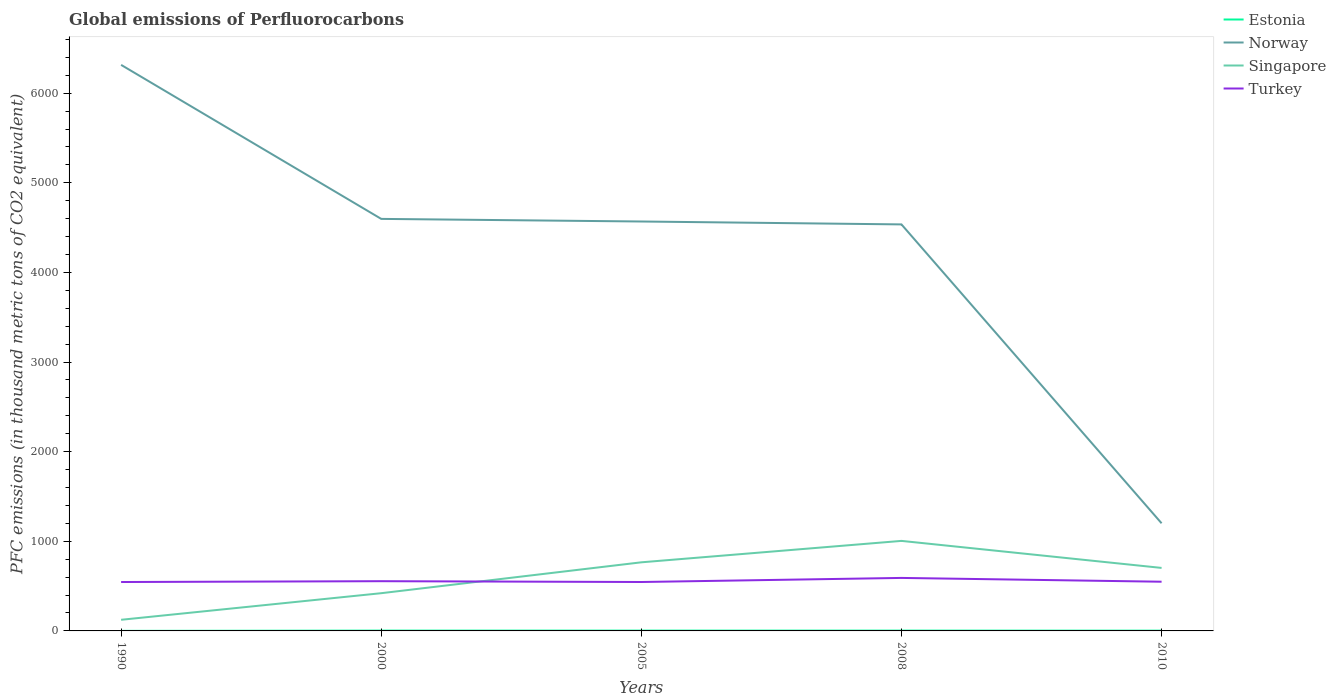Across all years, what is the maximum global emissions of Perfluorocarbons in Turkey?
Ensure brevity in your answer.  545.6. In which year was the global emissions of Perfluorocarbons in Turkey maximum?
Your answer should be very brief. 1990. What is the total global emissions of Perfluorocarbons in Norway in the graph?
Offer a terse response. 1780. What is the difference between the highest and the second highest global emissions of Perfluorocarbons in Singapore?
Your response must be concise. 880.3. Is the global emissions of Perfluorocarbons in Singapore strictly greater than the global emissions of Perfluorocarbons in Turkey over the years?
Your answer should be very brief. No. How many lines are there?
Give a very brief answer. 4. What is the difference between two consecutive major ticks on the Y-axis?
Your response must be concise. 1000. Does the graph contain any zero values?
Offer a very short reply. No. Does the graph contain grids?
Give a very brief answer. No. How are the legend labels stacked?
Your answer should be very brief. Vertical. What is the title of the graph?
Make the answer very short. Global emissions of Perfluorocarbons. Does "Yemen, Rep." appear as one of the legend labels in the graph?
Your answer should be compact. No. What is the label or title of the X-axis?
Provide a succinct answer. Years. What is the label or title of the Y-axis?
Give a very brief answer. PFC emissions (in thousand metric tons of CO2 equivalent). What is the PFC emissions (in thousand metric tons of CO2 equivalent) in Norway in 1990?
Your answer should be compact. 6315.7. What is the PFC emissions (in thousand metric tons of CO2 equivalent) in Singapore in 1990?
Provide a succinct answer. 124.2. What is the PFC emissions (in thousand metric tons of CO2 equivalent) in Turkey in 1990?
Give a very brief answer. 545.6. What is the PFC emissions (in thousand metric tons of CO2 equivalent) of Norway in 2000?
Make the answer very short. 4597.3. What is the PFC emissions (in thousand metric tons of CO2 equivalent) in Singapore in 2000?
Provide a succinct answer. 420.9. What is the PFC emissions (in thousand metric tons of CO2 equivalent) of Turkey in 2000?
Give a very brief answer. 554.9. What is the PFC emissions (in thousand metric tons of CO2 equivalent) of Estonia in 2005?
Offer a very short reply. 3.4. What is the PFC emissions (in thousand metric tons of CO2 equivalent) of Norway in 2005?
Make the answer very short. 4568.1. What is the PFC emissions (in thousand metric tons of CO2 equivalent) of Singapore in 2005?
Offer a terse response. 765.5. What is the PFC emissions (in thousand metric tons of CO2 equivalent) of Turkey in 2005?
Make the answer very short. 545.9. What is the PFC emissions (in thousand metric tons of CO2 equivalent) of Estonia in 2008?
Ensure brevity in your answer.  3.4. What is the PFC emissions (in thousand metric tons of CO2 equivalent) in Norway in 2008?
Your answer should be compact. 4535.7. What is the PFC emissions (in thousand metric tons of CO2 equivalent) of Singapore in 2008?
Provide a short and direct response. 1004.5. What is the PFC emissions (in thousand metric tons of CO2 equivalent) in Turkey in 2008?
Make the answer very short. 591.4. What is the PFC emissions (in thousand metric tons of CO2 equivalent) in Norway in 2010?
Offer a terse response. 1201. What is the PFC emissions (in thousand metric tons of CO2 equivalent) in Singapore in 2010?
Offer a very short reply. 703. What is the PFC emissions (in thousand metric tons of CO2 equivalent) of Turkey in 2010?
Your response must be concise. 549. Across all years, what is the maximum PFC emissions (in thousand metric tons of CO2 equivalent) of Estonia?
Give a very brief answer. 3.5. Across all years, what is the maximum PFC emissions (in thousand metric tons of CO2 equivalent) of Norway?
Your response must be concise. 6315.7. Across all years, what is the maximum PFC emissions (in thousand metric tons of CO2 equivalent) in Singapore?
Your response must be concise. 1004.5. Across all years, what is the maximum PFC emissions (in thousand metric tons of CO2 equivalent) of Turkey?
Give a very brief answer. 591.4. Across all years, what is the minimum PFC emissions (in thousand metric tons of CO2 equivalent) in Estonia?
Your answer should be very brief. 0.5. Across all years, what is the minimum PFC emissions (in thousand metric tons of CO2 equivalent) of Norway?
Offer a very short reply. 1201. Across all years, what is the minimum PFC emissions (in thousand metric tons of CO2 equivalent) of Singapore?
Keep it short and to the point. 124.2. Across all years, what is the minimum PFC emissions (in thousand metric tons of CO2 equivalent) in Turkey?
Offer a very short reply. 545.6. What is the total PFC emissions (in thousand metric tons of CO2 equivalent) of Estonia in the graph?
Your answer should be compact. 13.8. What is the total PFC emissions (in thousand metric tons of CO2 equivalent) of Norway in the graph?
Offer a very short reply. 2.12e+04. What is the total PFC emissions (in thousand metric tons of CO2 equivalent) in Singapore in the graph?
Make the answer very short. 3018.1. What is the total PFC emissions (in thousand metric tons of CO2 equivalent) in Turkey in the graph?
Keep it short and to the point. 2786.8. What is the difference between the PFC emissions (in thousand metric tons of CO2 equivalent) in Norway in 1990 and that in 2000?
Ensure brevity in your answer.  1718.4. What is the difference between the PFC emissions (in thousand metric tons of CO2 equivalent) of Singapore in 1990 and that in 2000?
Your answer should be very brief. -296.7. What is the difference between the PFC emissions (in thousand metric tons of CO2 equivalent) of Turkey in 1990 and that in 2000?
Provide a short and direct response. -9.3. What is the difference between the PFC emissions (in thousand metric tons of CO2 equivalent) of Estonia in 1990 and that in 2005?
Your answer should be compact. -2.9. What is the difference between the PFC emissions (in thousand metric tons of CO2 equivalent) in Norway in 1990 and that in 2005?
Give a very brief answer. 1747.6. What is the difference between the PFC emissions (in thousand metric tons of CO2 equivalent) of Singapore in 1990 and that in 2005?
Your answer should be compact. -641.3. What is the difference between the PFC emissions (in thousand metric tons of CO2 equivalent) in Turkey in 1990 and that in 2005?
Make the answer very short. -0.3. What is the difference between the PFC emissions (in thousand metric tons of CO2 equivalent) of Estonia in 1990 and that in 2008?
Provide a short and direct response. -2.9. What is the difference between the PFC emissions (in thousand metric tons of CO2 equivalent) of Norway in 1990 and that in 2008?
Your response must be concise. 1780. What is the difference between the PFC emissions (in thousand metric tons of CO2 equivalent) in Singapore in 1990 and that in 2008?
Offer a very short reply. -880.3. What is the difference between the PFC emissions (in thousand metric tons of CO2 equivalent) of Turkey in 1990 and that in 2008?
Keep it short and to the point. -45.8. What is the difference between the PFC emissions (in thousand metric tons of CO2 equivalent) in Estonia in 1990 and that in 2010?
Your response must be concise. -2.5. What is the difference between the PFC emissions (in thousand metric tons of CO2 equivalent) of Norway in 1990 and that in 2010?
Make the answer very short. 5114.7. What is the difference between the PFC emissions (in thousand metric tons of CO2 equivalent) of Singapore in 1990 and that in 2010?
Your answer should be compact. -578.8. What is the difference between the PFC emissions (in thousand metric tons of CO2 equivalent) in Norway in 2000 and that in 2005?
Offer a very short reply. 29.2. What is the difference between the PFC emissions (in thousand metric tons of CO2 equivalent) of Singapore in 2000 and that in 2005?
Your answer should be very brief. -344.6. What is the difference between the PFC emissions (in thousand metric tons of CO2 equivalent) in Turkey in 2000 and that in 2005?
Offer a terse response. 9. What is the difference between the PFC emissions (in thousand metric tons of CO2 equivalent) in Norway in 2000 and that in 2008?
Offer a terse response. 61.6. What is the difference between the PFC emissions (in thousand metric tons of CO2 equivalent) in Singapore in 2000 and that in 2008?
Offer a terse response. -583.6. What is the difference between the PFC emissions (in thousand metric tons of CO2 equivalent) of Turkey in 2000 and that in 2008?
Give a very brief answer. -36.5. What is the difference between the PFC emissions (in thousand metric tons of CO2 equivalent) in Estonia in 2000 and that in 2010?
Your response must be concise. 0.5. What is the difference between the PFC emissions (in thousand metric tons of CO2 equivalent) of Norway in 2000 and that in 2010?
Your answer should be very brief. 3396.3. What is the difference between the PFC emissions (in thousand metric tons of CO2 equivalent) in Singapore in 2000 and that in 2010?
Your answer should be compact. -282.1. What is the difference between the PFC emissions (in thousand metric tons of CO2 equivalent) in Turkey in 2000 and that in 2010?
Offer a very short reply. 5.9. What is the difference between the PFC emissions (in thousand metric tons of CO2 equivalent) of Estonia in 2005 and that in 2008?
Your answer should be very brief. 0. What is the difference between the PFC emissions (in thousand metric tons of CO2 equivalent) in Norway in 2005 and that in 2008?
Offer a very short reply. 32.4. What is the difference between the PFC emissions (in thousand metric tons of CO2 equivalent) of Singapore in 2005 and that in 2008?
Your answer should be compact. -239. What is the difference between the PFC emissions (in thousand metric tons of CO2 equivalent) in Turkey in 2005 and that in 2008?
Offer a terse response. -45.5. What is the difference between the PFC emissions (in thousand metric tons of CO2 equivalent) of Estonia in 2005 and that in 2010?
Provide a short and direct response. 0.4. What is the difference between the PFC emissions (in thousand metric tons of CO2 equivalent) of Norway in 2005 and that in 2010?
Provide a short and direct response. 3367.1. What is the difference between the PFC emissions (in thousand metric tons of CO2 equivalent) in Singapore in 2005 and that in 2010?
Offer a terse response. 62.5. What is the difference between the PFC emissions (in thousand metric tons of CO2 equivalent) of Turkey in 2005 and that in 2010?
Ensure brevity in your answer.  -3.1. What is the difference between the PFC emissions (in thousand metric tons of CO2 equivalent) of Estonia in 2008 and that in 2010?
Offer a very short reply. 0.4. What is the difference between the PFC emissions (in thousand metric tons of CO2 equivalent) in Norway in 2008 and that in 2010?
Ensure brevity in your answer.  3334.7. What is the difference between the PFC emissions (in thousand metric tons of CO2 equivalent) in Singapore in 2008 and that in 2010?
Make the answer very short. 301.5. What is the difference between the PFC emissions (in thousand metric tons of CO2 equivalent) in Turkey in 2008 and that in 2010?
Provide a succinct answer. 42.4. What is the difference between the PFC emissions (in thousand metric tons of CO2 equivalent) in Estonia in 1990 and the PFC emissions (in thousand metric tons of CO2 equivalent) in Norway in 2000?
Make the answer very short. -4596.8. What is the difference between the PFC emissions (in thousand metric tons of CO2 equivalent) in Estonia in 1990 and the PFC emissions (in thousand metric tons of CO2 equivalent) in Singapore in 2000?
Your answer should be compact. -420.4. What is the difference between the PFC emissions (in thousand metric tons of CO2 equivalent) of Estonia in 1990 and the PFC emissions (in thousand metric tons of CO2 equivalent) of Turkey in 2000?
Offer a terse response. -554.4. What is the difference between the PFC emissions (in thousand metric tons of CO2 equivalent) of Norway in 1990 and the PFC emissions (in thousand metric tons of CO2 equivalent) of Singapore in 2000?
Ensure brevity in your answer.  5894.8. What is the difference between the PFC emissions (in thousand metric tons of CO2 equivalent) of Norway in 1990 and the PFC emissions (in thousand metric tons of CO2 equivalent) of Turkey in 2000?
Your response must be concise. 5760.8. What is the difference between the PFC emissions (in thousand metric tons of CO2 equivalent) of Singapore in 1990 and the PFC emissions (in thousand metric tons of CO2 equivalent) of Turkey in 2000?
Offer a terse response. -430.7. What is the difference between the PFC emissions (in thousand metric tons of CO2 equivalent) of Estonia in 1990 and the PFC emissions (in thousand metric tons of CO2 equivalent) of Norway in 2005?
Offer a terse response. -4567.6. What is the difference between the PFC emissions (in thousand metric tons of CO2 equivalent) in Estonia in 1990 and the PFC emissions (in thousand metric tons of CO2 equivalent) in Singapore in 2005?
Make the answer very short. -765. What is the difference between the PFC emissions (in thousand metric tons of CO2 equivalent) of Estonia in 1990 and the PFC emissions (in thousand metric tons of CO2 equivalent) of Turkey in 2005?
Provide a short and direct response. -545.4. What is the difference between the PFC emissions (in thousand metric tons of CO2 equivalent) in Norway in 1990 and the PFC emissions (in thousand metric tons of CO2 equivalent) in Singapore in 2005?
Your answer should be compact. 5550.2. What is the difference between the PFC emissions (in thousand metric tons of CO2 equivalent) in Norway in 1990 and the PFC emissions (in thousand metric tons of CO2 equivalent) in Turkey in 2005?
Your answer should be compact. 5769.8. What is the difference between the PFC emissions (in thousand metric tons of CO2 equivalent) of Singapore in 1990 and the PFC emissions (in thousand metric tons of CO2 equivalent) of Turkey in 2005?
Ensure brevity in your answer.  -421.7. What is the difference between the PFC emissions (in thousand metric tons of CO2 equivalent) of Estonia in 1990 and the PFC emissions (in thousand metric tons of CO2 equivalent) of Norway in 2008?
Offer a very short reply. -4535.2. What is the difference between the PFC emissions (in thousand metric tons of CO2 equivalent) in Estonia in 1990 and the PFC emissions (in thousand metric tons of CO2 equivalent) in Singapore in 2008?
Keep it short and to the point. -1004. What is the difference between the PFC emissions (in thousand metric tons of CO2 equivalent) in Estonia in 1990 and the PFC emissions (in thousand metric tons of CO2 equivalent) in Turkey in 2008?
Provide a succinct answer. -590.9. What is the difference between the PFC emissions (in thousand metric tons of CO2 equivalent) of Norway in 1990 and the PFC emissions (in thousand metric tons of CO2 equivalent) of Singapore in 2008?
Your response must be concise. 5311.2. What is the difference between the PFC emissions (in thousand metric tons of CO2 equivalent) in Norway in 1990 and the PFC emissions (in thousand metric tons of CO2 equivalent) in Turkey in 2008?
Provide a succinct answer. 5724.3. What is the difference between the PFC emissions (in thousand metric tons of CO2 equivalent) in Singapore in 1990 and the PFC emissions (in thousand metric tons of CO2 equivalent) in Turkey in 2008?
Your response must be concise. -467.2. What is the difference between the PFC emissions (in thousand metric tons of CO2 equivalent) in Estonia in 1990 and the PFC emissions (in thousand metric tons of CO2 equivalent) in Norway in 2010?
Provide a short and direct response. -1200.5. What is the difference between the PFC emissions (in thousand metric tons of CO2 equivalent) in Estonia in 1990 and the PFC emissions (in thousand metric tons of CO2 equivalent) in Singapore in 2010?
Your answer should be compact. -702.5. What is the difference between the PFC emissions (in thousand metric tons of CO2 equivalent) of Estonia in 1990 and the PFC emissions (in thousand metric tons of CO2 equivalent) of Turkey in 2010?
Keep it short and to the point. -548.5. What is the difference between the PFC emissions (in thousand metric tons of CO2 equivalent) in Norway in 1990 and the PFC emissions (in thousand metric tons of CO2 equivalent) in Singapore in 2010?
Your answer should be compact. 5612.7. What is the difference between the PFC emissions (in thousand metric tons of CO2 equivalent) in Norway in 1990 and the PFC emissions (in thousand metric tons of CO2 equivalent) in Turkey in 2010?
Give a very brief answer. 5766.7. What is the difference between the PFC emissions (in thousand metric tons of CO2 equivalent) of Singapore in 1990 and the PFC emissions (in thousand metric tons of CO2 equivalent) of Turkey in 2010?
Provide a short and direct response. -424.8. What is the difference between the PFC emissions (in thousand metric tons of CO2 equivalent) in Estonia in 2000 and the PFC emissions (in thousand metric tons of CO2 equivalent) in Norway in 2005?
Your answer should be compact. -4564.6. What is the difference between the PFC emissions (in thousand metric tons of CO2 equivalent) of Estonia in 2000 and the PFC emissions (in thousand metric tons of CO2 equivalent) of Singapore in 2005?
Your response must be concise. -762. What is the difference between the PFC emissions (in thousand metric tons of CO2 equivalent) of Estonia in 2000 and the PFC emissions (in thousand metric tons of CO2 equivalent) of Turkey in 2005?
Make the answer very short. -542.4. What is the difference between the PFC emissions (in thousand metric tons of CO2 equivalent) in Norway in 2000 and the PFC emissions (in thousand metric tons of CO2 equivalent) in Singapore in 2005?
Offer a terse response. 3831.8. What is the difference between the PFC emissions (in thousand metric tons of CO2 equivalent) of Norway in 2000 and the PFC emissions (in thousand metric tons of CO2 equivalent) of Turkey in 2005?
Offer a very short reply. 4051.4. What is the difference between the PFC emissions (in thousand metric tons of CO2 equivalent) in Singapore in 2000 and the PFC emissions (in thousand metric tons of CO2 equivalent) in Turkey in 2005?
Make the answer very short. -125. What is the difference between the PFC emissions (in thousand metric tons of CO2 equivalent) of Estonia in 2000 and the PFC emissions (in thousand metric tons of CO2 equivalent) of Norway in 2008?
Your answer should be very brief. -4532.2. What is the difference between the PFC emissions (in thousand metric tons of CO2 equivalent) in Estonia in 2000 and the PFC emissions (in thousand metric tons of CO2 equivalent) in Singapore in 2008?
Your response must be concise. -1001. What is the difference between the PFC emissions (in thousand metric tons of CO2 equivalent) in Estonia in 2000 and the PFC emissions (in thousand metric tons of CO2 equivalent) in Turkey in 2008?
Provide a short and direct response. -587.9. What is the difference between the PFC emissions (in thousand metric tons of CO2 equivalent) of Norway in 2000 and the PFC emissions (in thousand metric tons of CO2 equivalent) of Singapore in 2008?
Your answer should be very brief. 3592.8. What is the difference between the PFC emissions (in thousand metric tons of CO2 equivalent) of Norway in 2000 and the PFC emissions (in thousand metric tons of CO2 equivalent) of Turkey in 2008?
Your answer should be compact. 4005.9. What is the difference between the PFC emissions (in thousand metric tons of CO2 equivalent) in Singapore in 2000 and the PFC emissions (in thousand metric tons of CO2 equivalent) in Turkey in 2008?
Your answer should be very brief. -170.5. What is the difference between the PFC emissions (in thousand metric tons of CO2 equivalent) in Estonia in 2000 and the PFC emissions (in thousand metric tons of CO2 equivalent) in Norway in 2010?
Your answer should be very brief. -1197.5. What is the difference between the PFC emissions (in thousand metric tons of CO2 equivalent) in Estonia in 2000 and the PFC emissions (in thousand metric tons of CO2 equivalent) in Singapore in 2010?
Provide a succinct answer. -699.5. What is the difference between the PFC emissions (in thousand metric tons of CO2 equivalent) in Estonia in 2000 and the PFC emissions (in thousand metric tons of CO2 equivalent) in Turkey in 2010?
Make the answer very short. -545.5. What is the difference between the PFC emissions (in thousand metric tons of CO2 equivalent) in Norway in 2000 and the PFC emissions (in thousand metric tons of CO2 equivalent) in Singapore in 2010?
Offer a very short reply. 3894.3. What is the difference between the PFC emissions (in thousand metric tons of CO2 equivalent) of Norway in 2000 and the PFC emissions (in thousand metric tons of CO2 equivalent) of Turkey in 2010?
Your response must be concise. 4048.3. What is the difference between the PFC emissions (in thousand metric tons of CO2 equivalent) in Singapore in 2000 and the PFC emissions (in thousand metric tons of CO2 equivalent) in Turkey in 2010?
Provide a short and direct response. -128.1. What is the difference between the PFC emissions (in thousand metric tons of CO2 equivalent) in Estonia in 2005 and the PFC emissions (in thousand metric tons of CO2 equivalent) in Norway in 2008?
Offer a terse response. -4532.3. What is the difference between the PFC emissions (in thousand metric tons of CO2 equivalent) in Estonia in 2005 and the PFC emissions (in thousand metric tons of CO2 equivalent) in Singapore in 2008?
Make the answer very short. -1001.1. What is the difference between the PFC emissions (in thousand metric tons of CO2 equivalent) of Estonia in 2005 and the PFC emissions (in thousand metric tons of CO2 equivalent) of Turkey in 2008?
Your response must be concise. -588. What is the difference between the PFC emissions (in thousand metric tons of CO2 equivalent) in Norway in 2005 and the PFC emissions (in thousand metric tons of CO2 equivalent) in Singapore in 2008?
Offer a terse response. 3563.6. What is the difference between the PFC emissions (in thousand metric tons of CO2 equivalent) in Norway in 2005 and the PFC emissions (in thousand metric tons of CO2 equivalent) in Turkey in 2008?
Offer a very short reply. 3976.7. What is the difference between the PFC emissions (in thousand metric tons of CO2 equivalent) in Singapore in 2005 and the PFC emissions (in thousand metric tons of CO2 equivalent) in Turkey in 2008?
Your response must be concise. 174.1. What is the difference between the PFC emissions (in thousand metric tons of CO2 equivalent) in Estonia in 2005 and the PFC emissions (in thousand metric tons of CO2 equivalent) in Norway in 2010?
Give a very brief answer. -1197.6. What is the difference between the PFC emissions (in thousand metric tons of CO2 equivalent) in Estonia in 2005 and the PFC emissions (in thousand metric tons of CO2 equivalent) in Singapore in 2010?
Offer a very short reply. -699.6. What is the difference between the PFC emissions (in thousand metric tons of CO2 equivalent) of Estonia in 2005 and the PFC emissions (in thousand metric tons of CO2 equivalent) of Turkey in 2010?
Make the answer very short. -545.6. What is the difference between the PFC emissions (in thousand metric tons of CO2 equivalent) in Norway in 2005 and the PFC emissions (in thousand metric tons of CO2 equivalent) in Singapore in 2010?
Keep it short and to the point. 3865.1. What is the difference between the PFC emissions (in thousand metric tons of CO2 equivalent) in Norway in 2005 and the PFC emissions (in thousand metric tons of CO2 equivalent) in Turkey in 2010?
Offer a terse response. 4019.1. What is the difference between the PFC emissions (in thousand metric tons of CO2 equivalent) of Singapore in 2005 and the PFC emissions (in thousand metric tons of CO2 equivalent) of Turkey in 2010?
Offer a terse response. 216.5. What is the difference between the PFC emissions (in thousand metric tons of CO2 equivalent) in Estonia in 2008 and the PFC emissions (in thousand metric tons of CO2 equivalent) in Norway in 2010?
Offer a very short reply. -1197.6. What is the difference between the PFC emissions (in thousand metric tons of CO2 equivalent) of Estonia in 2008 and the PFC emissions (in thousand metric tons of CO2 equivalent) of Singapore in 2010?
Keep it short and to the point. -699.6. What is the difference between the PFC emissions (in thousand metric tons of CO2 equivalent) in Estonia in 2008 and the PFC emissions (in thousand metric tons of CO2 equivalent) in Turkey in 2010?
Offer a very short reply. -545.6. What is the difference between the PFC emissions (in thousand metric tons of CO2 equivalent) of Norway in 2008 and the PFC emissions (in thousand metric tons of CO2 equivalent) of Singapore in 2010?
Provide a short and direct response. 3832.7. What is the difference between the PFC emissions (in thousand metric tons of CO2 equivalent) in Norway in 2008 and the PFC emissions (in thousand metric tons of CO2 equivalent) in Turkey in 2010?
Your response must be concise. 3986.7. What is the difference between the PFC emissions (in thousand metric tons of CO2 equivalent) of Singapore in 2008 and the PFC emissions (in thousand metric tons of CO2 equivalent) of Turkey in 2010?
Give a very brief answer. 455.5. What is the average PFC emissions (in thousand metric tons of CO2 equivalent) in Estonia per year?
Your response must be concise. 2.76. What is the average PFC emissions (in thousand metric tons of CO2 equivalent) in Norway per year?
Give a very brief answer. 4243.56. What is the average PFC emissions (in thousand metric tons of CO2 equivalent) in Singapore per year?
Your response must be concise. 603.62. What is the average PFC emissions (in thousand metric tons of CO2 equivalent) of Turkey per year?
Your answer should be very brief. 557.36. In the year 1990, what is the difference between the PFC emissions (in thousand metric tons of CO2 equivalent) in Estonia and PFC emissions (in thousand metric tons of CO2 equivalent) in Norway?
Your answer should be very brief. -6315.2. In the year 1990, what is the difference between the PFC emissions (in thousand metric tons of CO2 equivalent) of Estonia and PFC emissions (in thousand metric tons of CO2 equivalent) of Singapore?
Your response must be concise. -123.7. In the year 1990, what is the difference between the PFC emissions (in thousand metric tons of CO2 equivalent) of Estonia and PFC emissions (in thousand metric tons of CO2 equivalent) of Turkey?
Offer a terse response. -545.1. In the year 1990, what is the difference between the PFC emissions (in thousand metric tons of CO2 equivalent) of Norway and PFC emissions (in thousand metric tons of CO2 equivalent) of Singapore?
Ensure brevity in your answer.  6191.5. In the year 1990, what is the difference between the PFC emissions (in thousand metric tons of CO2 equivalent) of Norway and PFC emissions (in thousand metric tons of CO2 equivalent) of Turkey?
Ensure brevity in your answer.  5770.1. In the year 1990, what is the difference between the PFC emissions (in thousand metric tons of CO2 equivalent) in Singapore and PFC emissions (in thousand metric tons of CO2 equivalent) in Turkey?
Provide a short and direct response. -421.4. In the year 2000, what is the difference between the PFC emissions (in thousand metric tons of CO2 equivalent) of Estonia and PFC emissions (in thousand metric tons of CO2 equivalent) of Norway?
Provide a succinct answer. -4593.8. In the year 2000, what is the difference between the PFC emissions (in thousand metric tons of CO2 equivalent) in Estonia and PFC emissions (in thousand metric tons of CO2 equivalent) in Singapore?
Make the answer very short. -417.4. In the year 2000, what is the difference between the PFC emissions (in thousand metric tons of CO2 equivalent) in Estonia and PFC emissions (in thousand metric tons of CO2 equivalent) in Turkey?
Make the answer very short. -551.4. In the year 2000, what is the difference between the PFC emissions (in thousand metric tons of CO2 equivalent) of Norway and PFC emissions (in thousand metric tons of CO2 equivalent) of Singapore?
Your response must be concise. 4176.4. In the year 2000, what is the difference between the PFC emissions (in thousand metric tons of CO2 equivalent) of Norway and PFC emissions (in thousand metric tons of CO2 equivalent) of Turkey?
Give a very brief answer. 4042.4. In the year 2000, what is the difference between the PFC emissions (in thousand metric tons of CO2 equivalent) in Singapore and PFC emissions (in thousand metric tons of CO2 equivalent) in Turkey?
Give a very brief answer. -134. In the year 2005, what is the difference between the PFC emissions (in thousand metric tons of CO2 equivalent) in Estonia and PFC emissions (in thousand metric tons of CO2 equivalent) in Norway?
Ensure brevity in your answer.  -4564.7. In the year 2005, what is the difference between the PFC emissions (in thousand metric tons of CO2 equivalent) in Estonia and PFC emissions (in thousand metric tons of CO2 equivalent) in Singapore?
Offer a terse response. -762.1. In the year 2005, what is the difference between the PFC emissions (in thousand metric tons of CO2 equivalent) in Estonia and PFC emissions (in thousand metric tons of CO2 equivalent) in Turkey?
Your response must be concise. -542.5. In the year 2005, what is the difference between the PFC emissions (in thousand metric tons of CO2 equivalent) of Norway and PFC emissions (in thousand metric tons of CO2 equivalent) of Singapore?
Give a very brief answer. 3802.6. In the year 2005, what is the difference between the PFC emissions (in thousand metric tons of CO2 equivalent) of Norway and PFC emissions (in thousand metric tons of CO2 equivalent) of Turkey?
Offer a very short reply. 4022.2. In the year 2005, what is the difference between the PFC emissions (in thousand metric tons of CO2 equivalent) in Singapore and PFC emissions (in thousand metric tons of CO2 equivalent) in Turkey?
Your answer should be compact. 219.6. In the year 2008, what is the difference between the PFC emissions (in thousand metric tons of CO2 equivalent) of Estonia and PFC emissions (in thousand metric tons of CO2 equivalent) of Norway?
Your response must be concise. -4532.3. In the year 2008, what is the difference between the PFC emissions (in thousand metric tons of CO2 equivalent) of Estonia and PFC emissions (in thousand metric tons of CO2 equivalent) of Singapore?
Your response must be concise. -1001.1. In the year 2008, what is the difference between the PFC emissions (in thousand metric tons of CO2 equivalent) of Estonia and PFC emissions (in thousand metric tons of CO2 equivalent) of Turkey?
Keep it short and to the point. -588. In the year 2008, what is the difference between the PFC emissions (in thousand metric tons of CO2 equivalent) in Norway and PFC emissions (in thousand metric tons of CO2 equivalent) in Singapore?
Provide a succinct answer. 3531.2. In the year 2008, what is the difference between the PFC emissions (in thousand metric tons of CO2 equivalent) in Norway and PFC emissions (in thousand metric tons of CO2 equivalent) in Turkey?
Your response must be concise. 3944.3. In the year 2008, what is the difference between the PFC emissions (in thousand metric tons of CO2 equivalent) of Singapore and PFC emissions (in thousand metric tons of CO2 equivalent) of Turkey?
Your response must be concise. 413.1. In the year 2010, what is the difference between the PFC emissions (in thousand metric tons of CO2 equivalent) in Estonia and PFC emissions (in thousand metric tons of CO2 equivalent) in Norway?
Offer a very short reply. -1198. In the year 2010, what is the difference between the PFC emissions (in thousand metric tons of CO2 equivalent) in Estonia and PFC emissions (in thousand metric tons of CO2 equivalent) in Singapore?
Ensure brevity in your answer.  -700. In the year 2010, what is the difference between the PFC emissions (in thousand metric tons of CO2 equivalent) in Estonia and PFC emissions (in thousand metric tons of CO2 equivalent) in Turkey?
Provide a succinct answer. -546. In the year 2010, what is the difference between the PFC emissions (in thousand metric tons of CO2 equivalent) of Norway and PFC emissions (in thousand metric tons of CO2 equivalent) of Singapore?
Offer a very short reply. 498. In the year 2010, what is the difference between the PFC emissions (in thousand metric tons of CO2 equivalent) in Norway and PFC emissions (in thousand metric tons of CO2 equivalent) in Turkey?
Your answer should be very brief. 652. In the year 2010, what is the difference between the PFC emissions (in thousand metric tons of CO2 equivalent) of Singapore and PFC emissions (in thousand metric tons of CO2 equivalent) of Turkey?
Give a very brief answer. 154. What is the ratio of the PFC emissions (in thousand metric tons of CO2 equivalent) in Estonia in 1990 to that in 2000?
Give a very brief answer. 0.14. What is the ratio of the PFC emissions (in thousand metric tons of CO2 equivalent) of Norway in 1990 to that in 2000?
Make the answer very short. 1.37. What is the ratio of the PFC emissions (in thousand metric tons of CO2 equivalent) of Singapore in 1990 to that in 2000?
Your response must be concise. 0.3. What is the ratio of the PFC emissions (in thousand metric tons of CO2 equivalent) in Turkey in 1990 to that in 2000?
Your answer should be compact. 0.98. What is the ratio of the PFC emissions (in thousand metric tons of CO2 equivalent) in Estonia in 1990 to that in 2005?
Give a very brief answer. 0.15. What is the ratio of the PFC emissions (in thousand metric tons of CO2 equivalent) of Norway in 1990 to that in 2005?
Make the answer very short. 1.38. What is the ratio of the PFC emissions (in thousand metric tons of CO2 equivalent) in Singapore in 1990 to that in 2005?
Offer a terse response. 0.16. What is the ratio of the PFC emissions (in thousand metric tons of CO2 equivalent) in Turkey in 1990 to that in 2005?
Make the answer very short. 1. What is the ratio of the PFC emissions (in thousand metric tons of CO2 equivalent) in Estonia in 1990 to that in 2008?
Your answer should be compact. 0.15. What is the ratio of the PFC emissions (in thousand metric tons of CO2 equivalent) in Norway in 1990 to that in 2008?
Offer a very short reply. 1.39. What is the ratio of the PFC emissions (in thousand metric tons of CO2 equivalent) in Singapore in 1990 to that in 2008?
Provide a short and direct response. 0.12. What is the ratio of the PFC emissions (in thousand metric tons of CO2 equivalent) in Turkey in 1990 to that in 2008?
Ensure brevity in your answer.  0.92. What is the ratio of the PFC emissions (in thousand metric tons of CO2 equivalent) of Norway in 1990 to that in 2010?
Your response must be concise. 5.26. What is the ratio of the PFC emissions (in thousand metric tons of CO2 equivalent) of Singapore in 1990 to that in 2010?
Make the answer very short. 0.18. What is the ratio of the PFC emissions (in thousand metric tons of CO2 equivalent) in Turkey in 1990 to that in 2010?
Keep it short and to the point. 0.99. What is the ratio of the PFC emissions (in thousand metric tons of CO2 equivalent) in Estonia in 2000 to that in 2005?
Give a very brief answer. 1.03. What is the ratio of the PFC emissions (in thousand metric tons of CO2 equivalent) in Norway in 2000 to that in 2005?
Your answer should be very brief. 1.01. What is the ratio of the PFC emissions (in thousand metric tons of CO2 equivalent) in Singapore in 2000 to that in 2005?
Offer a terse response. 0.55. What is the ratio of the PFC emissions (in thousand metric tons of CO2 equivalent) of Turkey in 2000 to that in 2005?
Provide a short and direct response. 1.02. What is the ratio of the PFC emissions (in thousand metric tons of CO2 equivalent) of Estonia in 2000 to that in 2008?
Your answer should be compact. 1.03. What is the ratio of the PFC emissions (in thousand metric tons of CO2 equivalent) of Norway in 2000 to that in 2008?
Offer a terse response. 1.01. What is the ratio of the PFC emissions (in thousand metric tons of CO2 equivalent) in Singapore in 2000 to that in 2008?
Provide a short and direct response. 0.42. What is the ratio of the PFC emissions (in thousand metric tons of CO2 equivalent) in Turkey in 2000 to that in 2008?
Ensure brevity in your answer.  0.94. What is the ratio of the PFC emissions (in thousand metric tons of CO2 equivalent) of Norway in 2000 to that in 2010?
Make the answer very short. 3.83. What is the ratio of the PFC emissions (in thousand metric tons of CO2 equivalent) in Singapore in 2000 to that in 2010?
Offer a terse response. 0.6. What is the ratio of the PFC emissions (in thousand metric tons of CO2 equivalent) of Turkey in 2000 to that in 2010?
Offer a very short reply. 1.01. What is the ratio of the PFC emissions (in thousand metric tons of CO2 equivalent) of Norway in 2005 to that in 2008?
Your response must be concise. 1.01. What is the ratio of the PFC emissions (in thousand metric tons of CO2 equivalent) in Singapore in 2005 to that in 2008?
Provide a succinct answer. 0.76. What is the ratio of the PFC emissions (in thousand metric tons of CO2 equivalent) in Turkey in 2005 to that in 2008?
Offer a very short reply. 0.92. What is the ratio of the PFC emissions (in thousand metric tons of CO2 equivalent) in Estonia in 2005 to that in 2010?
Provide a succinct answer. 1.13. What is the ratio of the PFC emissions (in thousand metric tons of CO2 equivalent) of Norway in 2005 to that in 2010?
Your response must be concise. 3.8. What is the ratio of the PFC emissions (in thousand metric tons of CO2 equivalent) of Singapore in 2005 to that in 2010?
Make the answer very short. 1.09. What is the ratio of the PFC emissions (in thousand metric tons of CO2 equivalent) of Turkey in 2005 to that in 2010?
Your answer should be compact. 0.99. What is the ratio of the PFC emissions (in thousand metric tons of CO2 equivalent) in Estonia in 2008 to that in 2010?
Your answer should be very brief. 1.13. What is the ratio of the PFC emissions (in thousand metric tons of CO2 equivalent) in Norway in 2008 to that in 2010?
Keep it short and to the point. 3.78. What is the ratio of the PFC emissions (in thousand metric tons of CO2 equivalent) of Singapore in 2008 to that in 2010?
Keep it short and to the point. 1.43. What is the ratio of the PFC emissions (in thousand metric tons of CO2 equivalent) of Turkey in 2008 to that in 2010?
Provide a short and direct response. 1.08. What is the difference between the highest and the second highest PFC emissions (in thousand metric tons of CO2 equivalent) in Estonia?
Your answer should be compact. 0.1. What is the difference between the highest and the second highest PFC emissions (in thousand metric tons of CO2 equivalent) of Norway?
Provide a short and direct response. 1718.4. What is the difference between the highest and the second highest PFC emissions (in thousand metric tons of CO2 equivalent) of Singapore?
Offer a very short reply. 239. What is the difference between the highest and the second highest PFC emissions (in thousand metric tons of CO2 equivalent) in Turkey?
Make the answer very short. 36.5. What is the difference between the highest and the lowest PFC emissions (in thousand metric tons of CO2 equivalent) of Norway?
Offer a very short reply. 5114.7. What is the difference between the highest and the lowest PFC emissions (in thousand metric tons of CO2 equivalent) of Singapore?
Keep it short and to the point. 880.3. What is the difference between the highest and the lowest PFC emissions (in thousand metric tons of CO2 equivalent) of Turkey?
Give a very brief answer. 45.8. 